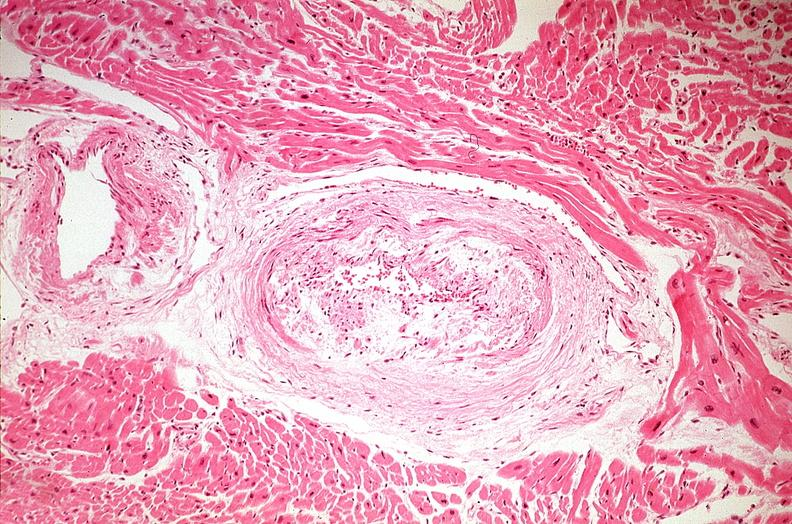s carcinoma present?
Answer the question using a single word or phrase. No 